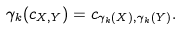Convert formula to latex. <formula><loc_0><loc_0><loc_500><loc_500>\gamma _ { k } ( c _ { X , Y } ) = c _ { \gamma _ { k } ( X ) , \gamma _ { k } ( Y ) } .</formula> 